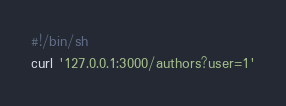Convert code to text. <code><loc_0><loc_0><loc_500><loc_500><_Bash_>#!/bin/sh
curl '127.0.0.1:3000/authors?user=1'
</code> 